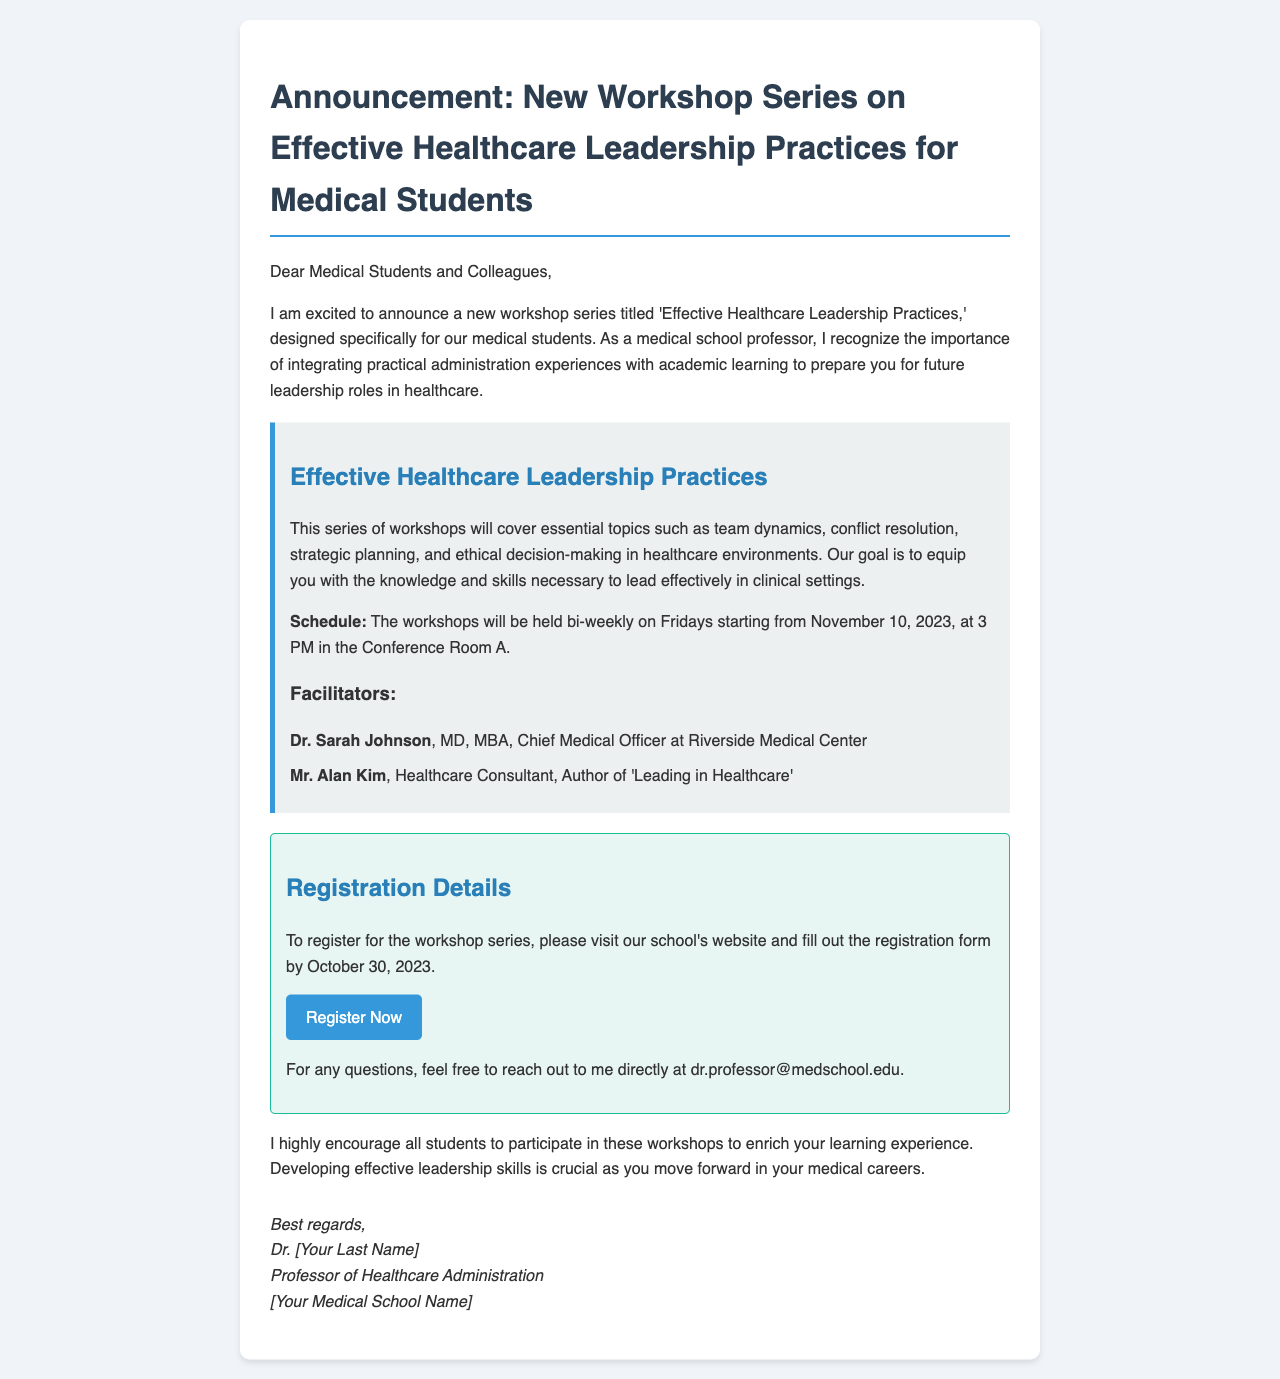What is the title of the workshop series? The title of the workshop series is explicitly mentioned in the announcement to be 'Effective Healthcare Leadership Practices.'
Answer: 'Effective Healthcare Leadership Practices' Who are the facilitators of the workshops? The document lists two facilitators: Dr. Sarah Johnson and Mr. Alan Kim.
Answer: Dr. Sarah Johnson and Mr. Alan Kim When does the workshop series start? The announcement specifies that the workshops will begin on November 10, 2023.
Answer: November 10, 2023 What time are the workshops scheduled to be held? The document states that the workshops will be held at 3 PM.
Answer: 3 PM How often will the workshops occur? The announcement mentions that the workshops will be held bi-weekly.
Answer: bi-weekly What is the registration deadline for the workshop series? The deadline for registration is stated in the document to be October 30, 2023.
Answer: October 30, 2023 Where can students register for the workshops? The document instructs students to visit the school's website to fill out the registration form.
Answer: school's website What is the main goal of the workshop series? The document indicates that the goal is to equip students with knowledge and skills necessary for effective leadership in healthcare.
Answer: equip students with knowledge and skills necessary for effective leadership 